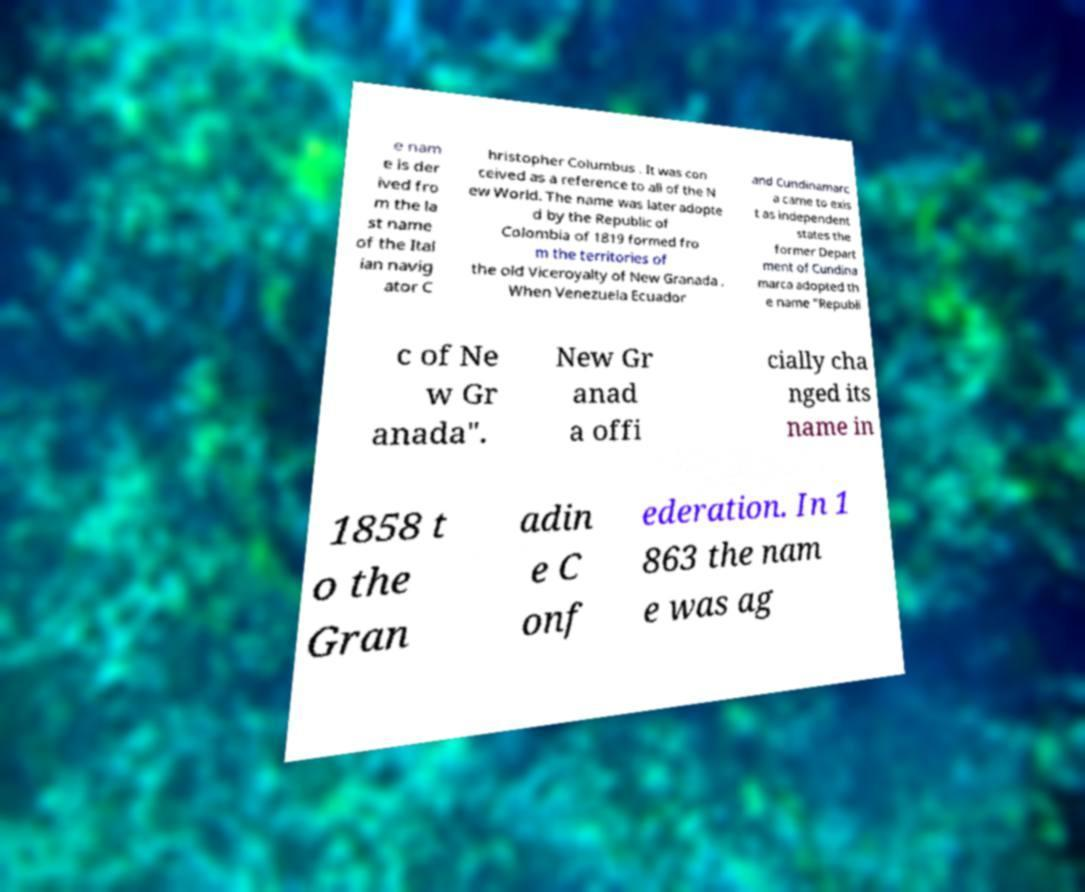Could you extract and type out the text from this image? e nam e is der ived fro m the la st name of the Ital ian navig ator C hristopher Columbus . It was con ceived as a reference to all of the N ew World. The name was later adopte d by the Republic of Colombia of 1819 formed fro m the territories of the old Viceroyalty of New Granada . When Venezuela Ecuador and Cundinamarc a came to exis t as independent states the former Depart ment of Cundina marca adopted th e name "Republi c of Ne w Gr anada". New Gr anad a offi cially cha nged its name in 1858 t o the Gran adin e C onf ederation. In 1 863 the nam e was ag 